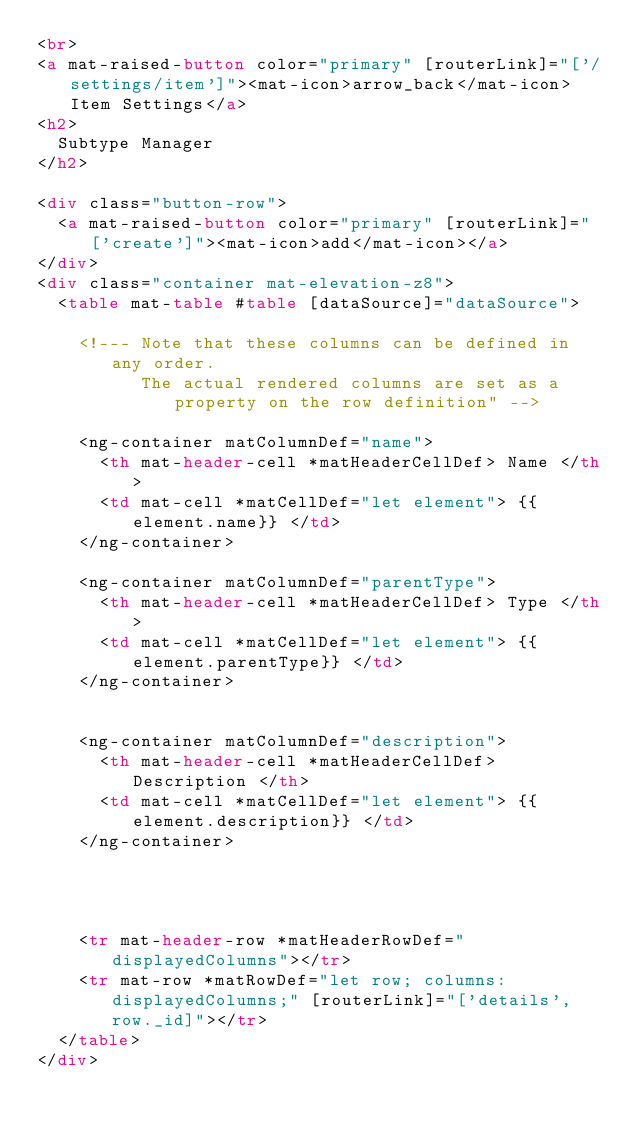Convert code to text. <code><loc_0><loc_0><loc_500><loc_500><_HTML_><br>
<a mat-raised-button color="primary" [routerLink]="['/settings/item']"><mat-icon>arrow_back</mat-icon> Item Settings</a>
<h2>
  Subtype Manager
</h2>

<div class="button-row">
  <a mat-raised-button color="primary" [routerLink]="['create']"><mat-icon>add</mat-icon></a>
</div>
<div class="container mat-elevation-z8">
  <table mat-table #table [dataSource]="dataSource">

    <!--- Note that these columns can be defined in any order.
          The actual rendered columns are set as a property on the row definition" -->

    <ng-container matColumnDef="name">
      <th mat-header-cell *matHeaderCellDef> Name </th>
      <td mat-cell *matCellDef="let element"> {{element.name}} </td>
    </ng-container>

    <ng-container matColumnDef="parentType">
      <th mat-header-cell *matHeaderCellDef> Type </th>
      <td mat-cell *matCellDef="let element"> {{element.parentType}} </td>
    </ng-container>


    <ng-container matColumnDef="description">
      <th mat-header-cell *matHeaderCellDef> Description </th>
      <td mat-cell *matCellDef="let element"> {{element.description}} </td>
    </ng-container>




    <tr mat-header-row *matHeaderRowDef="displayedColumns"></tr>
    <tr mat-row *matRowDef="let row; columns: displayedColumns;" [routerLink]="['details', row._id]"></tr>
  </table>
</div></code> 